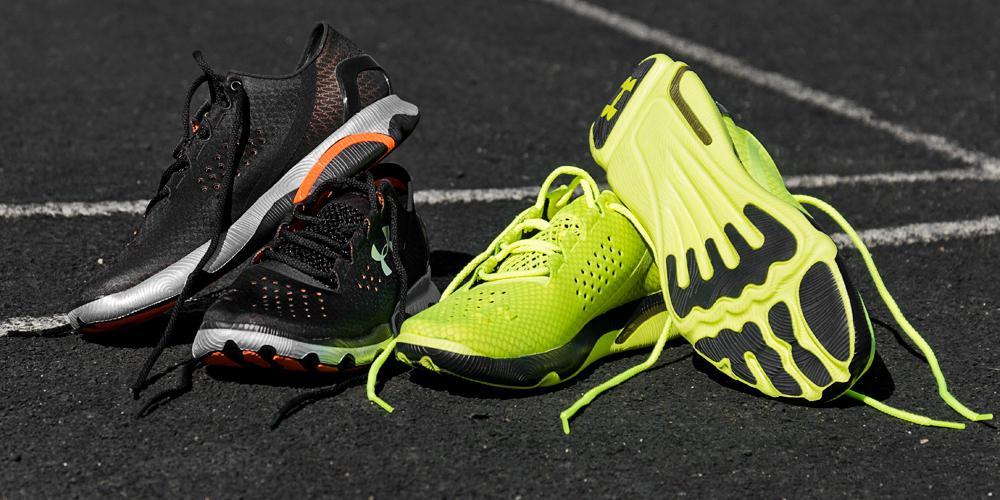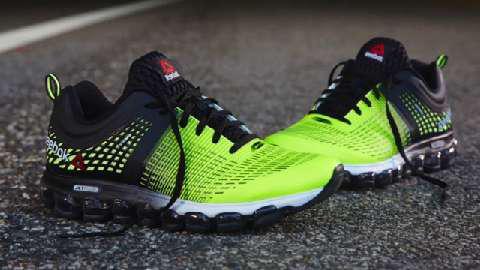The first image is the image on the left, the second image is the image on the right. Analyze the images presented: Is the assertion "Three or more of the shoes are at least partially green." valid? Answer yes or no. Yes. 